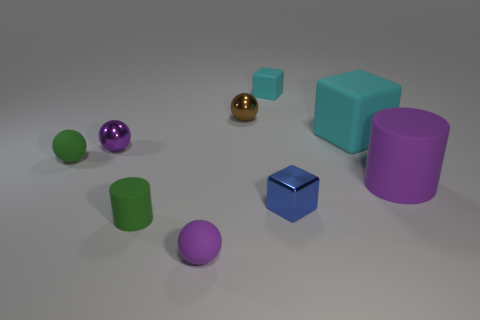Is the shape of the tiny green matte object that is in front of the tiny green ball the same as the purple matte object that is right of the small brown shiny ball? yes 